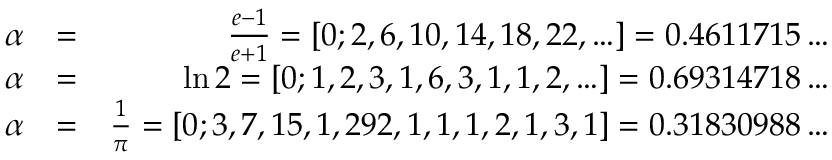<formula> <loc_0><loc_0><loc_500><loc_500>\begin{array} { r l r } { \alpha } & { = } & { \frac { e - 1 } { e + 1 } = [ 0 ; 2 , 6 , 1 0 , 1 4 , 1 8 , 2 2 , \dots ] = 0 . 4 6 1 1 7 1 5 \dots } \\ { \alpha } & { = } & { \ln 2 = [ 0 ; 1 , 2 , 3 , 1 , 6 , 3 , 1 , 1 , 2 , \dots ] = 0 . 6 9 3 1 4 7 1 8 \dots } \\ { \alpha } & { = } & { \frac { 1 } { \pi } = [ 0 ; 3 , 7 , 1 5 , 1 , 2 9 2 , 1 , 1 , 1 , 2 , 1 , 3 , 1 ] = 0 . 3 1 8 3 0 9 8 8 \dots } \end{array}</formula> 